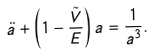Convert formula to latex. <formula><loc_0><loc_0><loc_500><loc_500>\ddot { a } + \left ( 1 - \frac { \tilde { V } } { E } \right ) a = \frac { 1 } { a ^ { 3 } } .</formula> 